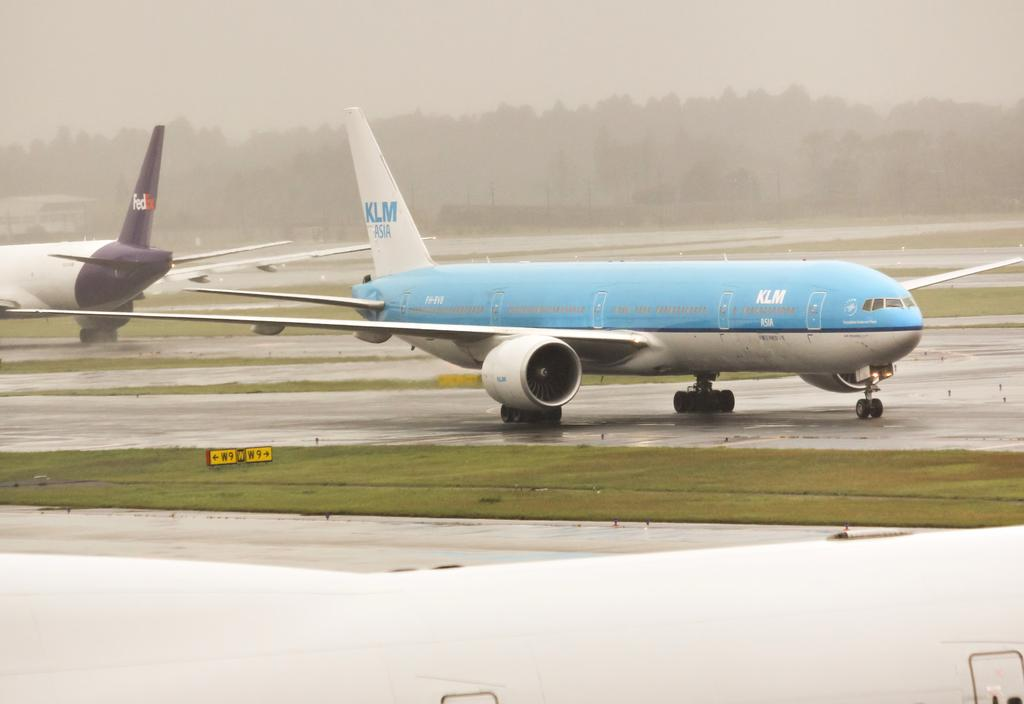What is the main subject of the image? The main subject of the image is airplanes. What else can be seen in the image besides airplanes? There are roads, grassy land, trees in the background, and the sky visible at the top of the image. What type of thrill can be experienced by the crows during the rainstorm in the image? There are no crows or rainstorm present in the image, so it is not possible to answer that question. 